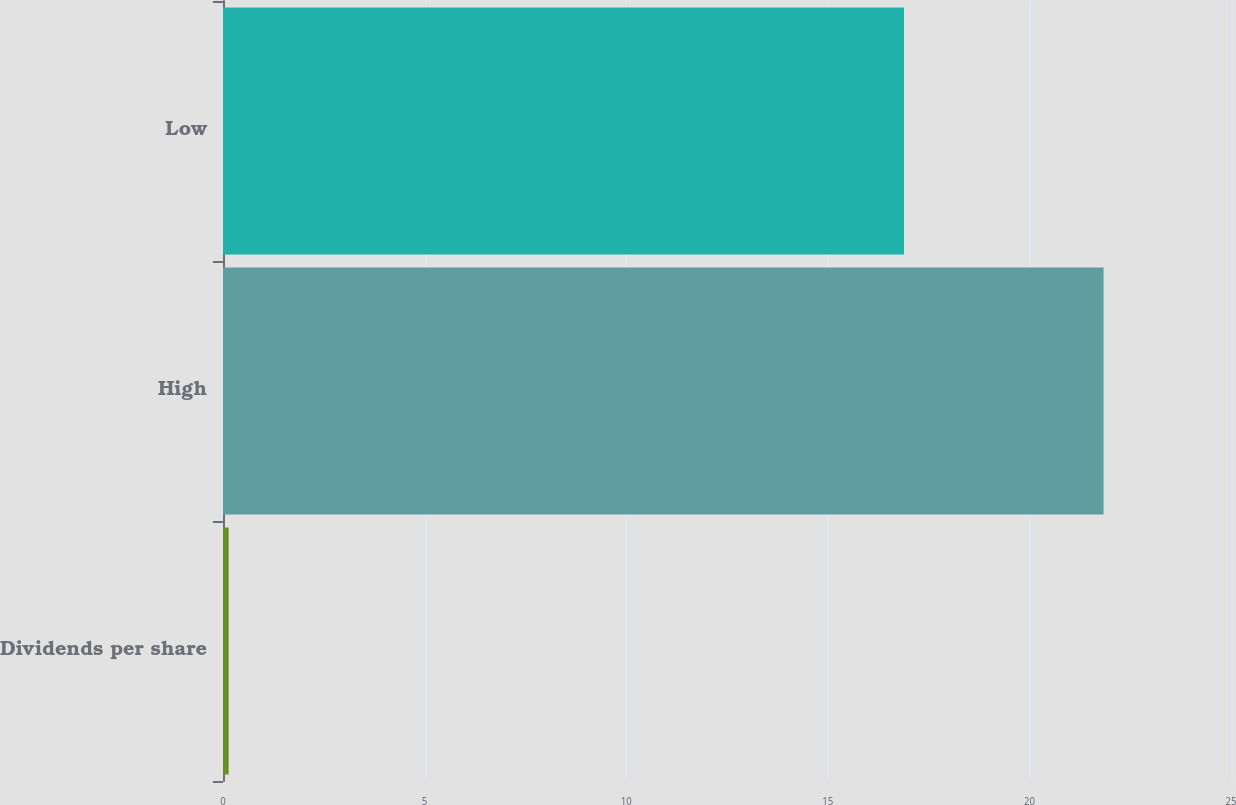Convert chart to OTSL. <chart><loc_0><loc_0><loc_500><loc_500><bar_chart><fcel>Dividends per share<fcel>High<fcel>Low<nl><fcel>0.14<fcel>21.84<fcel>16.89<nl></chart> 